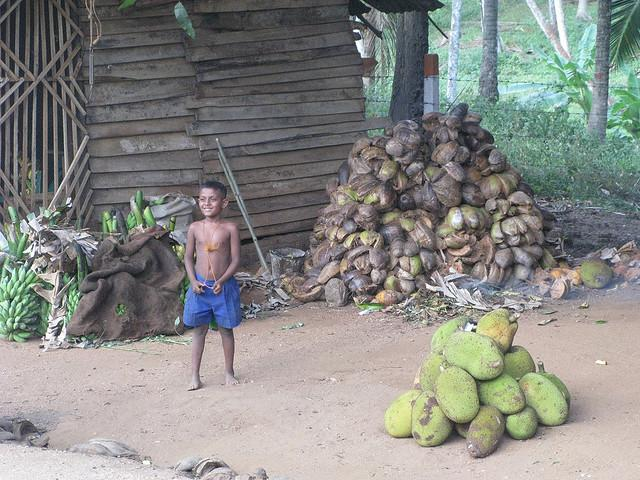What type of fruit are the green items on the boys right? coconut 